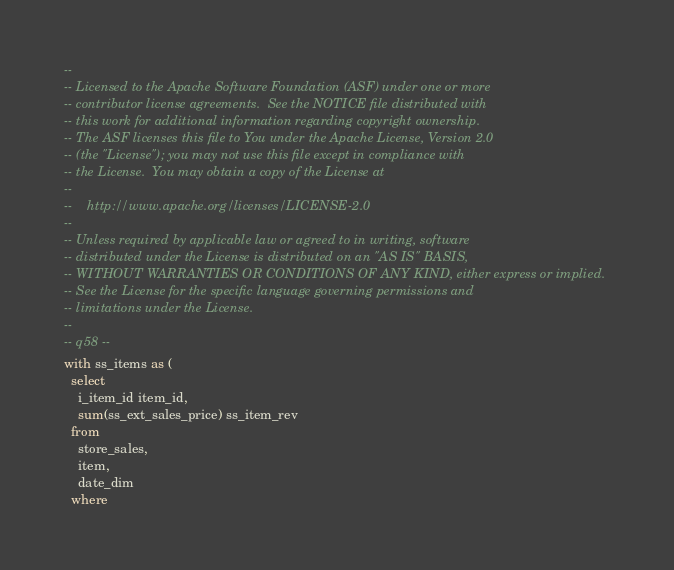Convert code to text. <code><loc_0><loc_0><loc_500><loc_500><_SQL_>--
-- Licensed to the Apache Software Foundation (ASF) under one or more
-- contributor license agreements.  See the NOTICE file distributed with
-- this work for additional information regarding copyright ownership.
-- The ASF licenses this file to You under the Apache License, Version 2.0
-- (the "License"); you may not use this file except in compliance with
-- the License.  You may obtain a copy of the License at
--
--    http://www.apache.org/licenses/LICENSE-2.0
--
-- Unless required by applicable law or agreed to in writing, software
-- distributed under the License is distributed on an "AS IS" BASIS,
-- WITHOUT WARRANTIES OR CONDITIONS OF ANY KIND, either express or implied.
-- See the License for the specific language governing permissions and
-- limitations under the License.
--
-- q58 --
with ss_items as (
  select
    i_item_id item_id,
    sum(ss_ext_sales_price) ss_item_rev
  from
    store_sales,
    item,
    date_dim
  where</code> 